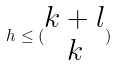Convert formula to latex. <formula><loc_0><loc_0><loc_500><loc_500>h \leq ( \begin{matrix} k + l \\ k \end{matrix} )</formula> 